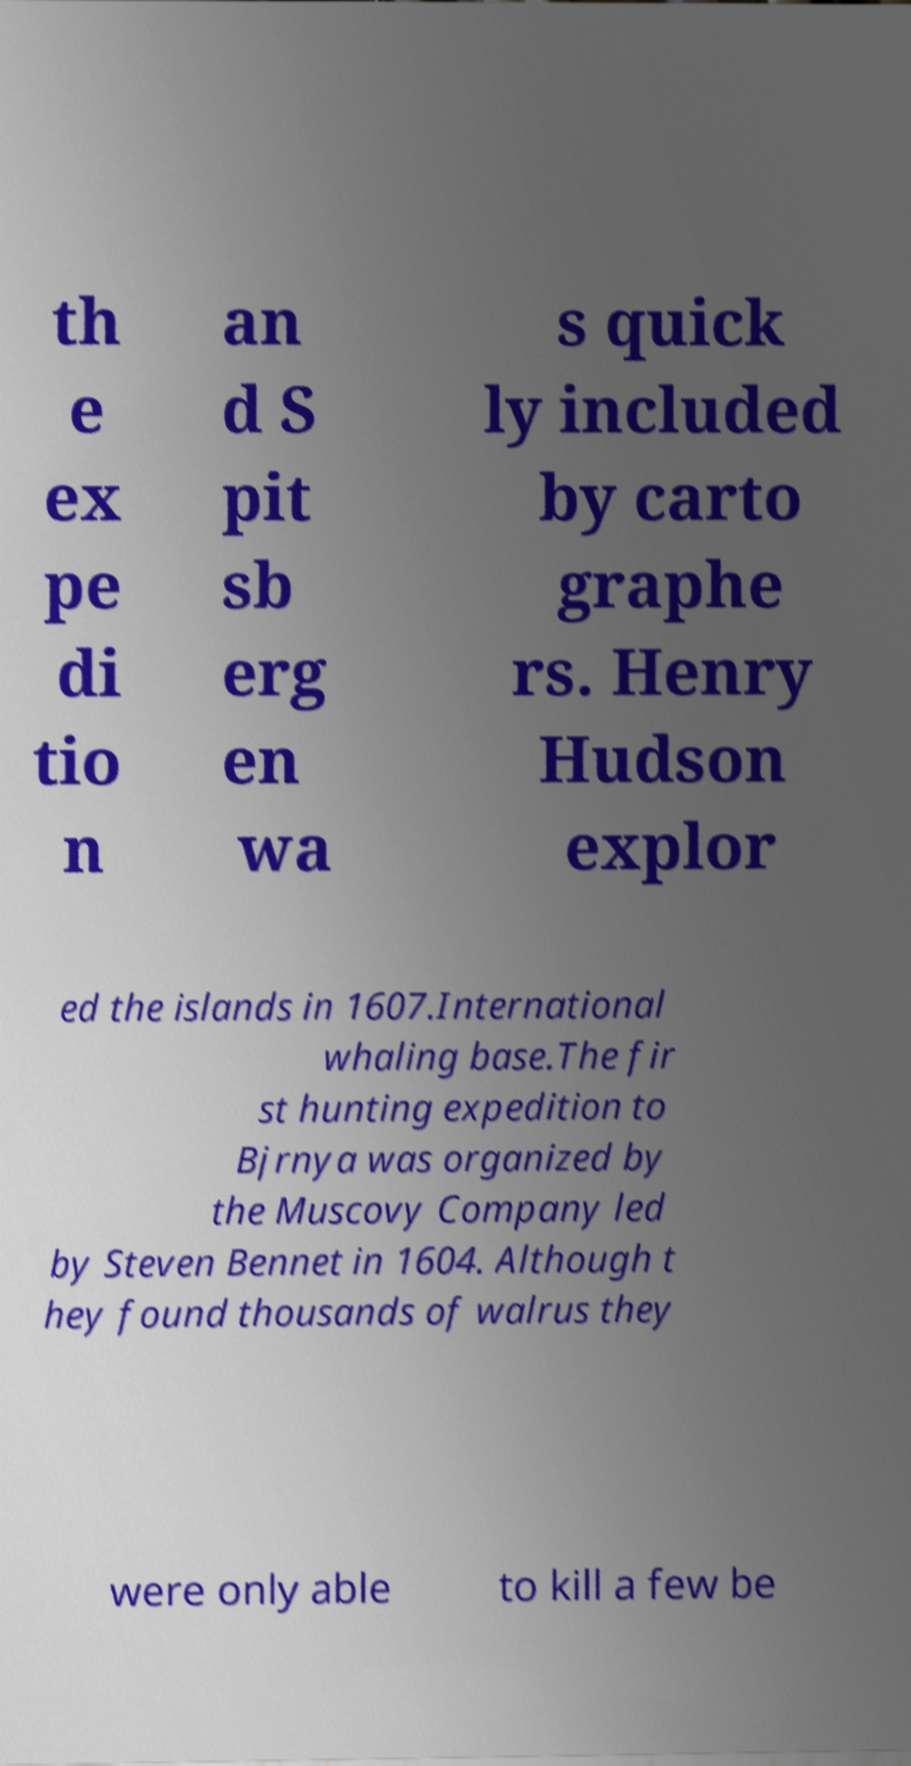Please read and relay the text visible in this image. What does it say? th e ex pe di tio n an d S pit sb erg en wa s quick ly included by carto graphe rs. Henry Hudson explor ed the islands in 1607.International whaling base.The fir st hunting expedition to Bjrnya was organized by the Muscovy Company led by Steven Bennet in 1604. Although t hey found thousands of walrus they were only able to kill a few be 